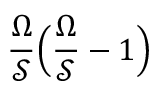<formula> <loc_0><loc_0><loc_500><loc_500>\frac { \Omega } { \mathcal { S } } \left ( \frac { \Omega } { \mathcal { S } } - 1 \right )</formula> 